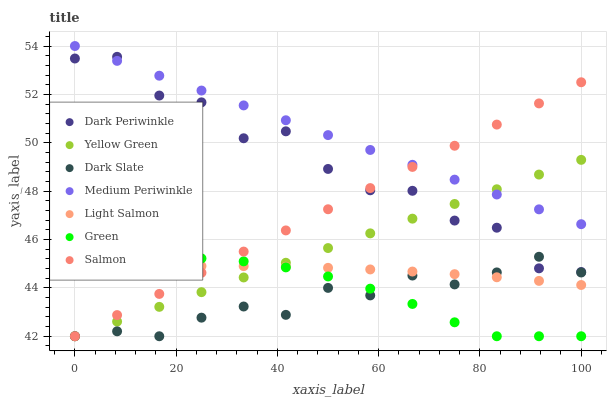Does Dark Slate have the minimum area under the curve?
Answer yes or no. Yes. Does Medium Periwinkle have the maximum area under the curve?
Answer yes or no. Yes. Does Yellow Green have the minimum area under the curve?
Answer yes or no. No. Does Yellow Green have the maximum area under the curve?
Answer yes or no. No. Is Yellow Green the smoothest?
Answer yes or no. Yes. Is Dark Periwinkle the roughest?
Answer yes or no. Yes. Is Salmon the smoothest?
Answer yes or no. No. Is Salmon the roughest?
Answer yes or no. No. Does Yellow Green have the lowest value?
Answer yes or no. Yes. Does Medium Periwinkle have the lowest value?
Answer yes or no. No. Does Medium Periwinkle have the highest value?
Answer yes or no. Yes. Does Yellow Green have the highest value?
Answer yes or no. No. Is Green less than Medium Periwinkle?
Answer yes or no. Yes. Is Medium Periwinkle greater than Light Salmon?
Answer yes or no. Yes. Does Light Salmon intersect Yellow Green?
Answer yes or no. Yes. Is Light Salmon less than Yellow Green?
Answer yes or no. No. Is Light Salmon greater than Yellow Green?
Answer yes or no. No. Does Green intersect Medium Periwinkle?
Answer yes or no. No. 